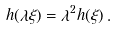Convert formula to latex. <formula><loc_0><loc_0><loc_500><loc_500>h ( \lambda \xi ) = \lambda ^ { 2 } h ( \xi ) \, .</formula> 